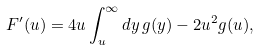<formula> <loc_0><loc_0><loc_500><loc_500>F ^ { \prime } ( u ) = 4 u \int _ { u } ^ { \infty } d y \, g ( y ) - 2 u ^ { 2 } g ( u ) ,</formula> 